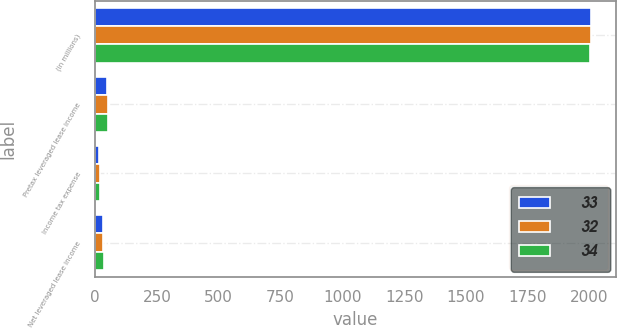Convert chart. <chart><loc_0><loc_0><loc_500><loc_500><stacked_bar_chart><ecel><fcel>(in millions)<fcel>Pretax leveraged lease income<fcel>Income tax expense<fcel>Net leveraged lease income<nl><fcel>33<fcel>2006<fcel>49<fcel>17<fcel>32<nl><fcel>32<fcel>2005<fcel>51<fcel>18<fcel>33<nl><fcel>34<fcel>2004<fcel>53<fcel>19<fcel>34<nl></chart> 